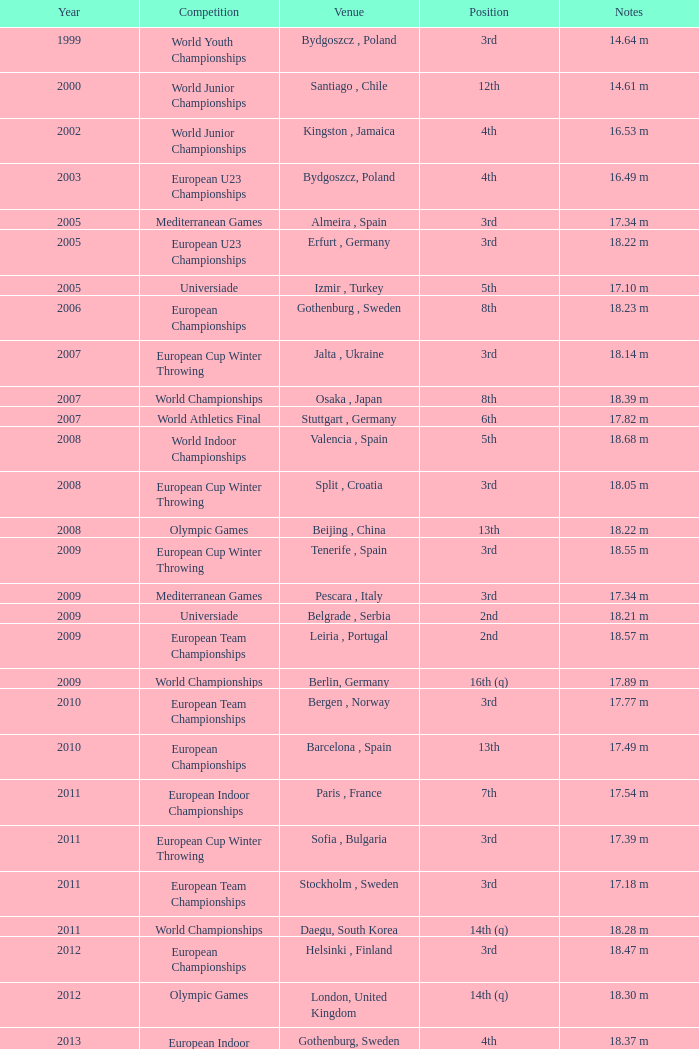What are the records for bydgoszcz, poland? 14.64 m, 16.49 m. 